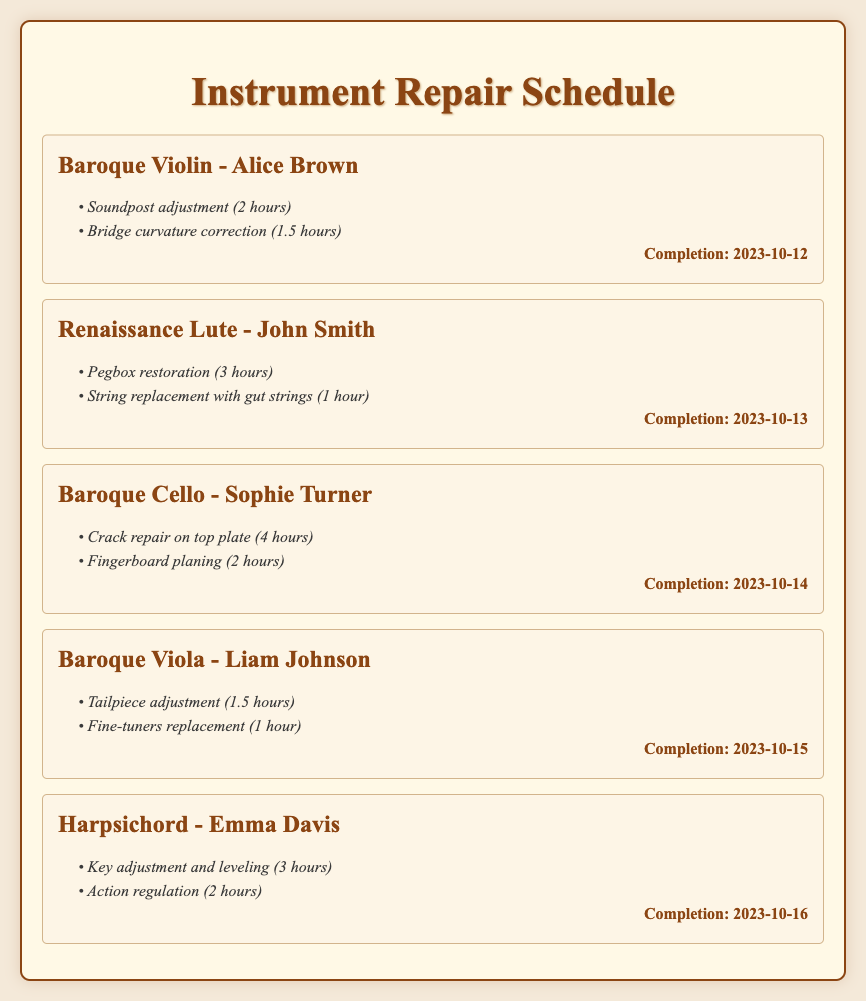what instrument is Alice Brown's scheduled for repair? The document lists the Baroque Violin as the instrument for Alice Brown.
Answer: Baroque Violin when is the completion date for the Renaissance Lute? The completion date listed for the Renaissance Lute is 2023-10-13.
Answer: 2023-10-13 how many hours are estimated for the crack repair on the Baroque Cello? The document states that the crack repair on the Baroque Cello is estimated to take 4 hours.
Answer: 4 hours who is scheduled to have their Baroque Viola repaired? The document indicates that the Baroque Viola is scheduled for repair for Liam Johnson.
Answer: Liam Johnson which tasks are scheduled for the Harpsichord? The tasks noted for the Harpsichord are key adjustment and leveling and action regulation.
Answer: Key adjustment and leveling, action regulation what is the total estimated time for repairs on the Baroque Viola? The document shows that the total estimated time for repairs on the Baroque Viola is 2.5 hours.
Answer: 2.5 hours which instrument requires a pegbox restoration? The document specifies that the Renaissance Lute requires a pegbox restoration.
Answer: Renaissance Lute what is the customer name associated with the Baroque Cello? The customer name for the Baroque Cello is Sophie Turner.
Answer: Sophie Turner how many tasks are listed for the Baroque Violin? The document indicates that there are two tasks listed for the Baroque Violin.
Answer: 2 tasks 